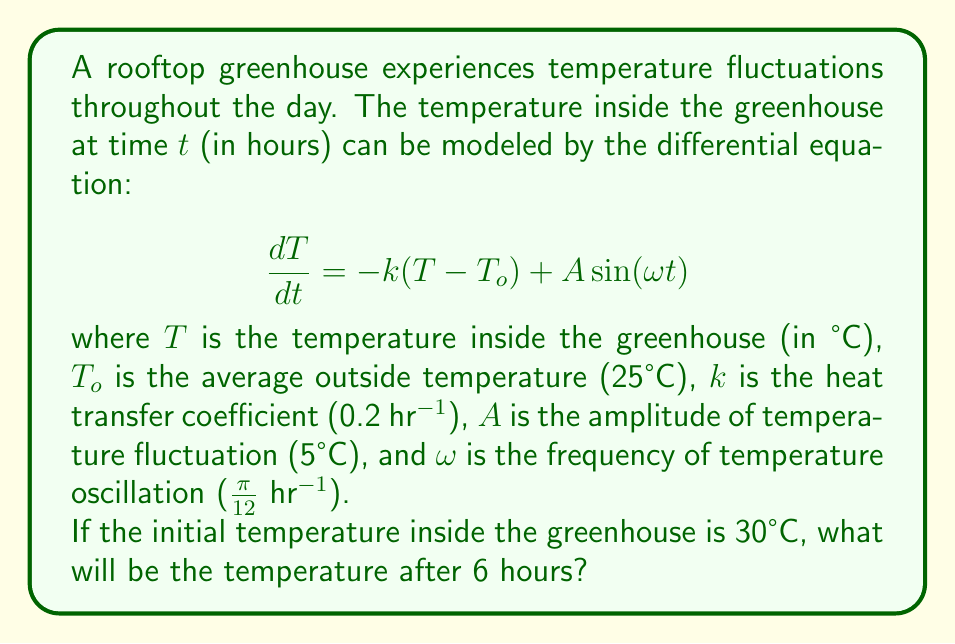Help me with this question. To solve this problem, we need to find the general solution to the given differential equation and then apply the initial condition.

1) The general solution to this non-homogeneous linear differential equation is:

   $$T(t) = T_p + C e^{-kt}$$

   where $T_p$ is the particular solution and $C$ is a constant.

2) The particular solution has the form:

   $$T_p = T_o + B\sin(\omega t) + D\cos(\omega t)$$

3) Substituting this into the original equation:

   $$B\omega\cos(\omega t) - D\omega\sin(\omega t) = -k(B\sin(\omega t) + D\cos(\omega t)) + A\sin(\omega t)$$

4) Comparing coefficients:

   $$B\omega = -kD$$
   $$-D\omega = -kB + A$$

5) Solving these equations:

   $$B = \frac{Ak}{k^2 + \omega^2}$$
   $$D = \frac{-A\omega}{k^2 + \omega^2}$$

6) Therefore, the particular solution is:

   $$T_p = 25 + \frac{5 \cdot 0.2}{0.2^2 + (\frac{\pi}{12})^2}\sin(\frac{\pi}{12}t) - \frac{5 \cdot \frac{\pi}{12}}{0.2^2 + (\frac{\pi}{12})^2}\cos(\frac{\pi}{12}t)$$

7) The general solution is:

   $$T(t) = 25 + 4.71\sin(\frac{\pi}{12}t) - 3.77\cos(\frac{\pi}{12}t) + Ce^{-0.2t}$$

8) Using the initial condition $T(0) = 30$:

   $$30 = 25 - 3.77 + C$$
   $$C = 8.77$$

9) The final solution is:

   $$T(t) = 25 + 4.71\sin(\frac{\pi}{12}t) - 3.77\cos(\frac{\pi}{12}t) + 8.77e^{-0.2t}$$

10) Evaluating at $t = 6$:

    $$T(6) = 25 + 4.71\sin(\frac{\pi}{2}) - 3.77\cos(\frac{\pi}{2}) + 8.77e^{-1.2}$$
Answer: $T(6) \approx 29.32°C$ 